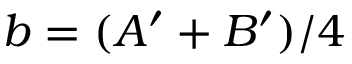Convert formula to latex. <formula><loc_0><loc_0><loc_500><loc_500>b = ( A ^ { \prime } + B ^ { \prime } ) / 4</formula> 